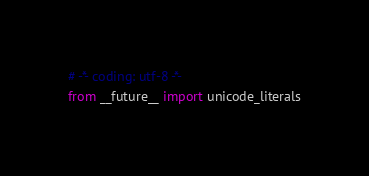Convert code to text. <code><loc_0><loc_0><loc_500><loc_500><_Python_># -*- coding: utf-8 -*-
from __future__ import unicode_literals
</code> 